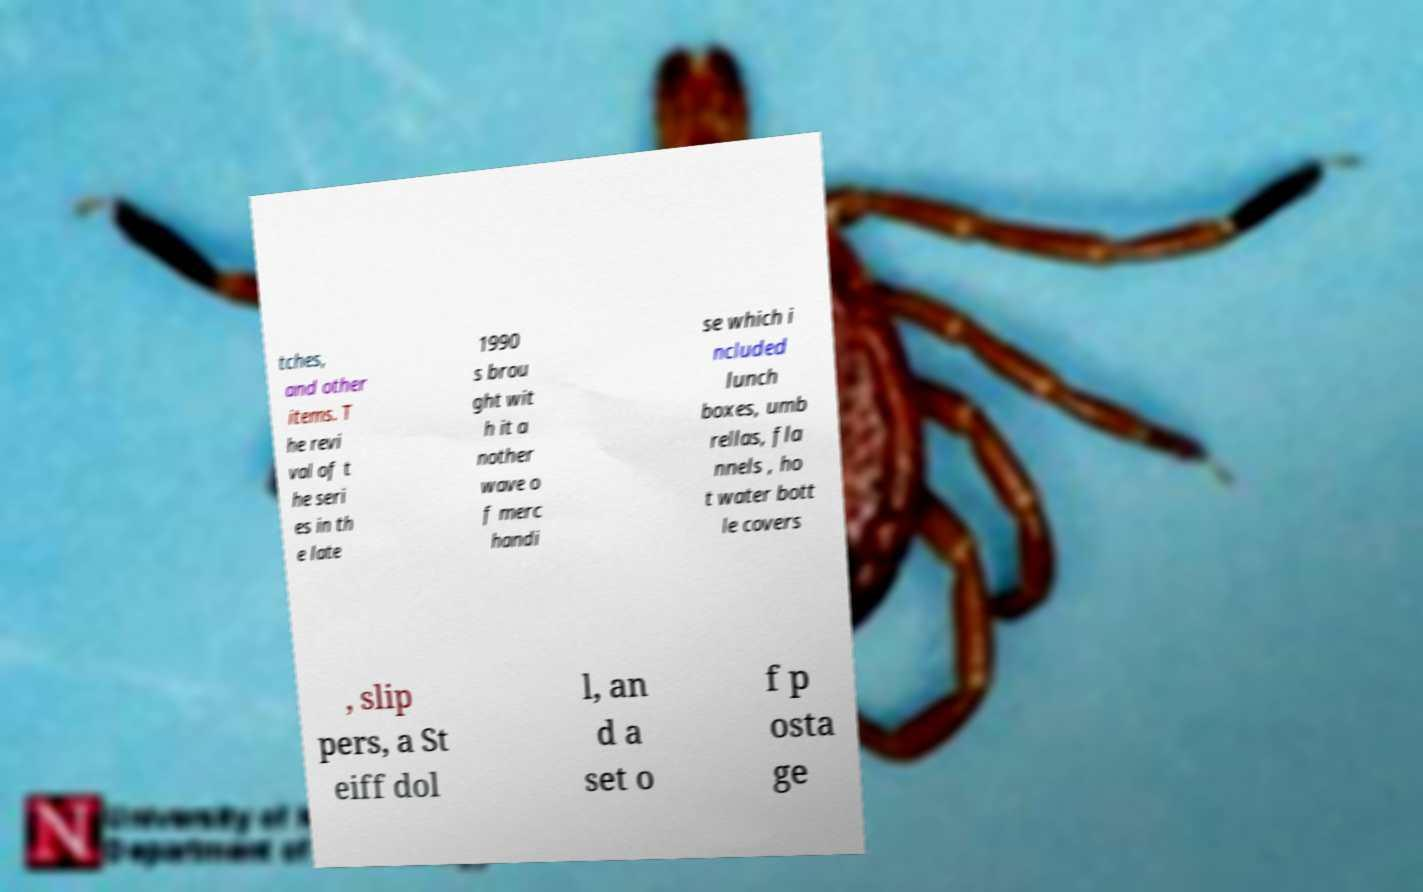There's text embedded in this image that I need extracted. Can you transcribe it verbatim? tches, and other items. T he revi val of t he seri es in th e late 1990 s brou ght wit h it a nother wave o f merc handi se which i ncluded lunch boxes, umb rellas, fla nnels , ho t water bott le covers , slip pers, a St eiff dol l, an d a set o f p osta ge 